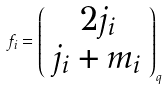Convert formula to latex. <formula><loc_0><loc_0><loc_500><loc_500>f _ { i } = \left ( \begin{array} { c } 2 j _ { i } \\ j _ { i } + m _ { i } \end{array} \right ) _ { q }</formula> 